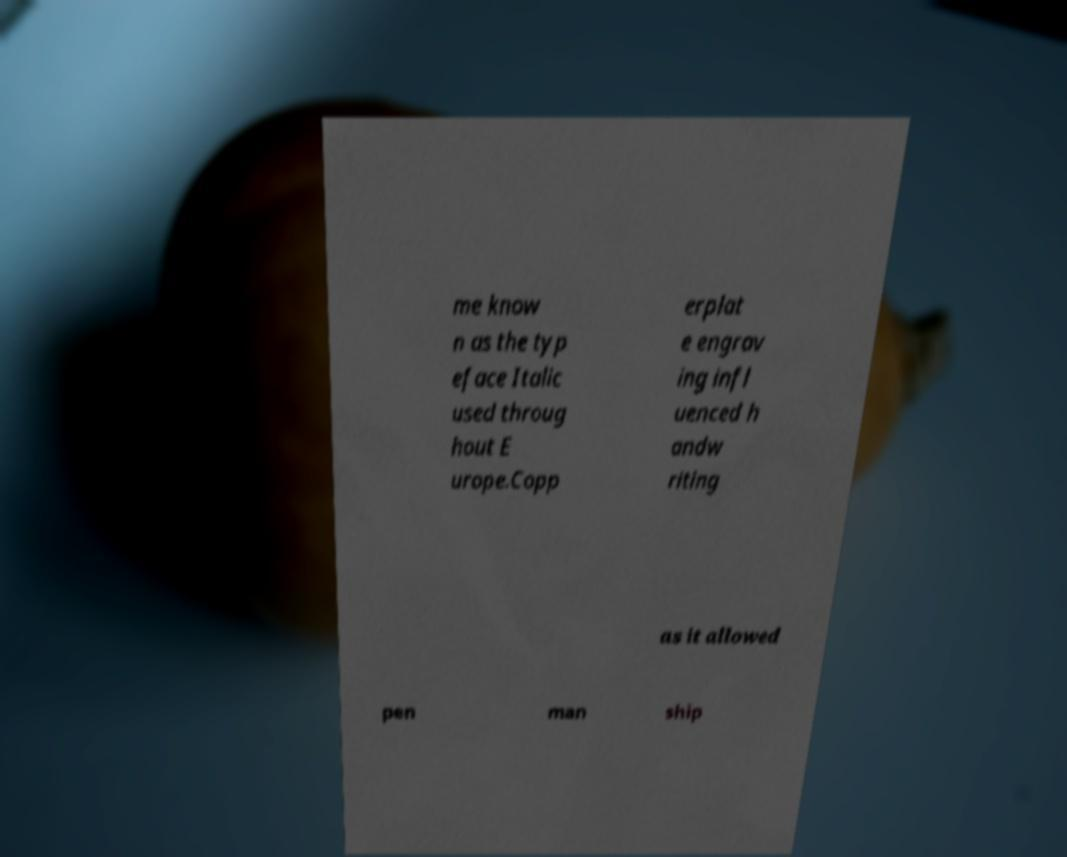What messages or text are displayed in this image? I need them in a readable, typed format. me know n as the typ eface Italic used throug hout E urope.Copp erplat e engrav ing infl uenced h andw riting as it allowed pen man ship 